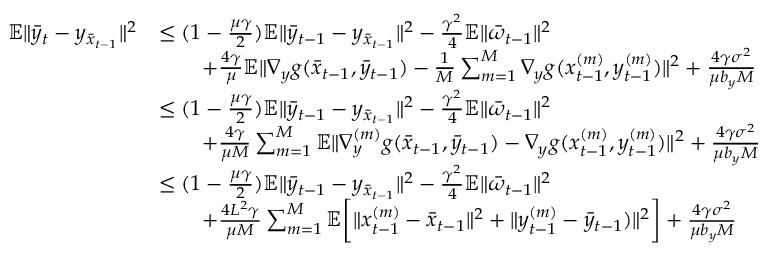Convert formula to latex. <formula><loc_0><loc_0><loc_500><loc_500>\begin{array} { r l } { \mathbb { E } \| \bar { y } _ { t } - y _ { \bar { x } _ { t - 1 } } \| ^ { 2 } } & { \leq ( 1 - \frac { \mu \gamma } { 2 } ) \mathbb { E } \| \bar { y } _ { t - 1 } - y _ { \bar { x } _ { t - 1 } } \| ^ { 2 } - \frac { \gamma ^ { 2 } } { 4 } \mathbb { E } \| \bar { \omega } _ { t - 1 } \| ^ { 2 } } \\ & { \quad + \frac { 4 \gamma } { \mu } \mathbb { E } \| \nabla _ { y } g ( \bar { x } _ { t - 1 } , \bar { y } _ { t - 1 } ) - \frac { 1 } { M } \sum _ { m = 1 } ^ { M } \nabla _ { y } g ( x _ { t - 1 } ^ { ( m ) } , y _ { t - 1 } ^ { ( m ) } ) \| ^ { 2 } + \frac { 4 \gamma \sigma ^ { 2 } } { \mu b _ { y } M } } \\ & { \leq ( 1 - \frac { \mu \gamma } { 2 } ) \mathbb { E } \| \bar { y } _ { t - 1 } - y _ { \bar { x } _ { t - 1 } } \| ^ { 2 } - \frac { \gamma ^ { 2 } } { 4 } \mathbb { E } \| \bar { \omega } _ { t - 1 } \| ^ { 2 } } \\ & { \quad + \frac { 4 \gamma } { \mu M } \sum _ { m = 1 } ^ { M } \mathbb { E } \| \nabla _ { y } ^ { ( m ) } g ( \bar { x } _ { t - 1 } , \bar { y } _ { t - 1 } ) - \nabla _ { y } g ( x _ { t - 1 } ^ { ( m ) } , y _ { t - 1 } ^ { ( m ) } ) \| ^ { 2 } + \frac { 4 \gamma \sigma ^ { 2 } } { \mu b _ { y } M } } \\ & { \leq ( 1 - \frac { \mu \gamma } { 2 } ) \mathbb { E } \| \bar { y } _ { t - 1 } - y _ { \bar { x } _ { t - 1 } } \| ^ { 2 } - \frac { \gamma ^ { 2 } } { 4 } \mathbb { E } \| \bar { \omega } _ { t - 1 } \| ^ { 2 } } \\ & { \quad + \frac { 4 L ^ { 2 } \gamma } { \mu M } \sum _ { m = 1 } ^ { M } \mathbb { E } \left [ \| x _ { t - 1 } ^ { ( m ) } - \bar { x } _ { t - 1 } \| ^ { 2 } + \| y _ { t - 1 } ^ { ( m ) } - \bar { y } _ { t - 1 } ) \| ^ { 2 } \right ] + \frac { 4 \gamma \sigma ^ { 2 } } { \mu b _ { y } M } } \end{array}</formula> 